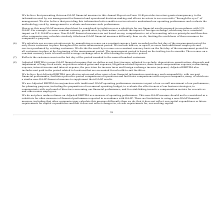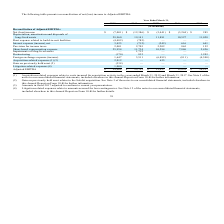According to Mimecast Limited's financial document, What is the Adjusted EBITDA in 2019? According to the financial document, $54,008 (in thousands). The relevant text states: "Adjusted EBITDA $ 54,008 $ 25,752 $ 12,457 $ 15,839 $ 14,227..." Also, What is the Adjusted EBITDA in 2018? According to the financial document, $25,752 (in thousands). The relevant text states: "Adjusted EBITDA $ 54,008 $ 25,752 $ 12,457 $ 15,839 $ 14,227..." Also, What was the Net (loss) income in 2019, 2018 and 2017 respectively? The document contains multiple relevant values: (7,001), (12,386), (5,441) (in thousands). From the document: "Net (loss) income $ (7,001) $ (12,386) $ (5,441) $ (3,244) $ 285 Net (loss) income $ (7,001) $ (12,386) $ (5,441) $ (3,244) $ 285 Net (loss) income $ ..." Also, can you calculate: What was the change in the Depreciation, amortization and disposals of long-lived assets from 2018 to 2019? Based on the calculation: 29,960 - 19,141, the result is 10819 (in thousands). This is based on the information: ", amortization and disposals of long-lived assets 29,960 19,141 11,881 10,527 11,028 ization and disposals of long-lived assets 29,960 19,141 11,881 10,527 11,028..." The key data points involved are: 19,141, 29,960. Also, can you calculate: What is the average Rent expense related to build-to-suit facilities between 2015-2019? To answer this question, I need to perform calculations using the financial data. The calculation is: -(4,482 + 785 + 0 + 0 + 0) / 5, which equals -1053.4 (in thousands). This is based on the information: "2019 2018 2017 2016 2015 ense related to build-to-suit facilities (4,482) (785) — — — Rent expense related to build-to-suit facilities (4,482) (785) — — —..." The key data points involved are: 4,482, 785. Additionally, In which year was Adjusted EBITDA less than 20,000 thousands? The document contains multiple relevant values: 2017, 2016, 2015. Locate and analyze adjusted ebitda in row 17. From the document: "2019 2018 2017 2016 2015 2019 2018 2017 2016 2015 2019 2018 2017 2016 2015..." 